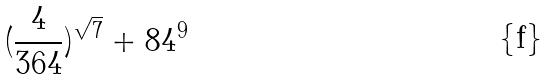<formula> <loc_0><loc_0><loc_500><loc_500>( \frac { 4 } { 3 6 4 } ) ^ { \sqrt { 7 } } + 8 4 ^ { 9 }</formula> 